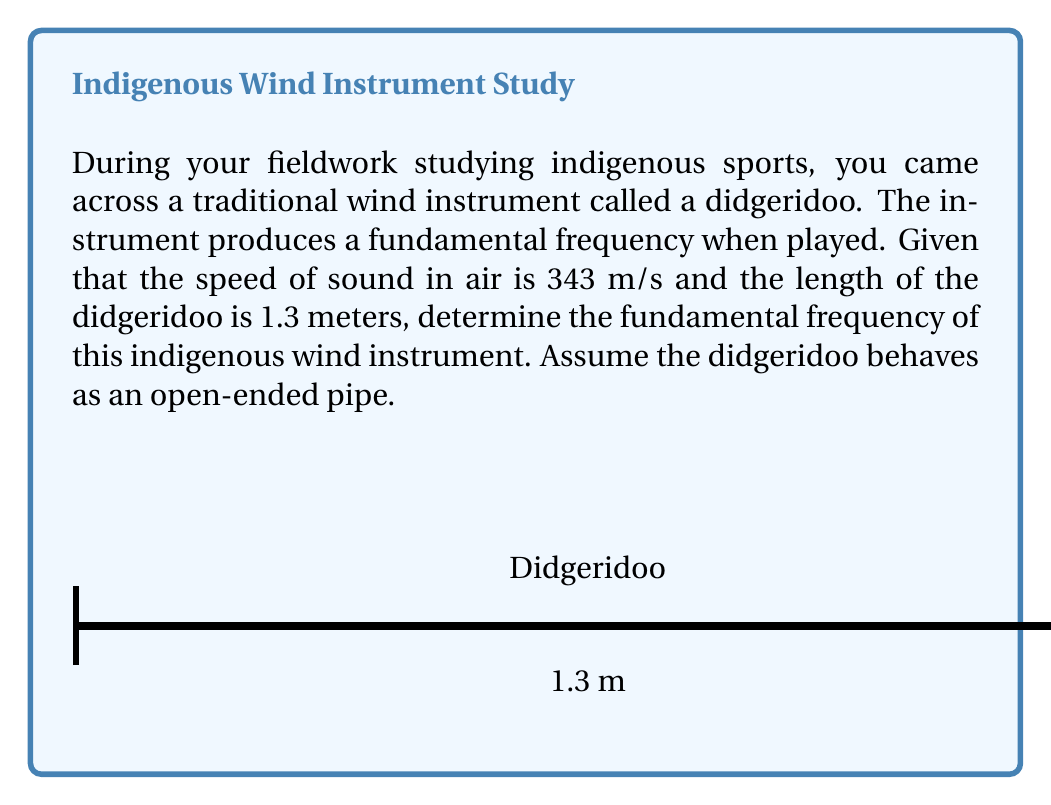Could you help me with this problem? To solve this problem, we'll use the formula for the fundamental frequency of an open-ended pipe:

$$f = \frac{v}{2L}$$

Where:
$f$ = fundamental frequency (Hz)
$v$ = speed of sound in air (m/s)
$L$ = length of the pipe (m)

Given:
$v = 343$ m/s
$L = 1.3$ m

Step 1: Substitute the values into the formula:

$$f = \frac{343}{2(1.3)}$$

Step 2: Simplify:

$$f = \frac{343}{2.6}$$

Step 3: Calculate the result:

$$f \approx 131.92 \text{ Hz}$$

Therefore, the fundamental frequency of the didgeridoo is approximately 131.92 Hz.
Answer: $131.92 \text{ Hz}$ 